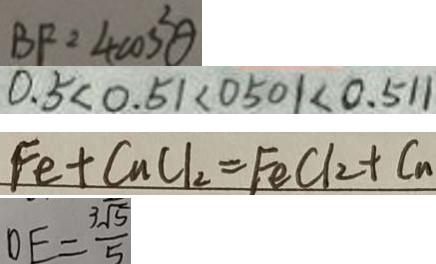Convert formula to latex. <formula><loc_0><loc_0><loc_500><loc_500>B F = 4 \cos ^ { 2 } \theta 
 0 . 5 < 0 . 5 1 < 0 5 0 1 < 0 . 5 1 1 
 F e + C u C l _ { 2 } = F e C l _ { 2 } + C _ { n } 
 D E = \frac { 3 \sqrt { 5 } } { 5 }</formula> 